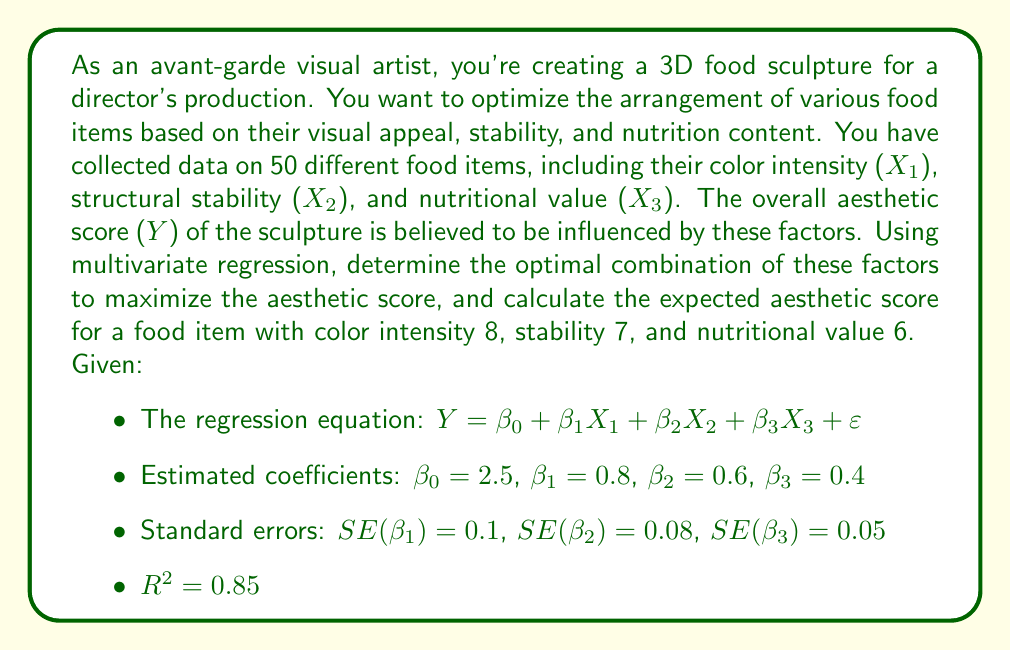Could you help me with this problem? To solve this problem, we'll follow these steps:

1. Interpret the regression equation and coefficients.
2. Determine the optimal combination of factors.
3. Calculate the expected aesthetic score for the given food item.
4. Assess the model's overall fit.

Step 1: Interpret the regression equation and coefficients

The regression equation is:

$Y = 2.5 + 0.8X_1 + 0.6X_2 + 0.4X_3 + \varepsilon$

Where:
- Y is the overall aesthetic score
- X₁ is color intensity
- X₂ is structural stability
- X₃ is nutritional value
- ε is the error term

The coefficients (β₁, β₂, β₃) represent the change in the aesthetic score for a one-unit increase in the respective variable, holding other variables constant.

Step 2: Determine the optimal combination of factors

To maximize the aesthetic score, we should prioritize the factors with the highest coefficients:
1. Color intensity (X₁): β₁ = 0.8
2. Structural stability (X₂): β₂ = 0.6
3. Nutritional value (X₃): β₃ = 0.4

The optimal arrangement should emphasize color intensity the most, followed by structural stability, and then nutritional value.

Step 3: Calculate the expected aesthetic score

For a food item with color intensity 8, stability 7, and nutritional value 6:

$Y = 2.5 + 0.8(8) + 0.6(7) + 0.4(6)$
$Y = 2.5 + 6.4 + 4.2 + 2.4$
$Y = 15.5$

Step 4: Assess the model's overall fit

The R² value of 0.85 indicates that 85% of the variance in the aesthetic score is explained by the model, which suggests a good fit.

To further assess the significance of each variable, we can calculate t-statistics:

$t_{\beta_1} = \frac{\beta_1}{SE(\beta_1)} = \frac{0.8}{0.1} = 8$
$t_{\beta_2} = \frac{\beta_2}{SE(\beta_2)} = \frac{0.6}{0.08} = 7.5$
$t_{\beta_3} = \frac{\beta_3}{SE(\beta_3)} = \frac{0.4}{0.05} = 8$

All t-statistics are greater than 2, indicating that all variables are statistically significant at the 0.05 level.
Answer: The optimal arrangement of food items in the 3D sculpture should prioritize color intensity, followed by structural stability, and then nutritional value. The expected aesthetic score for a food item with color intensity 8, stability 7, and nutritional value 6 is 15.5. 